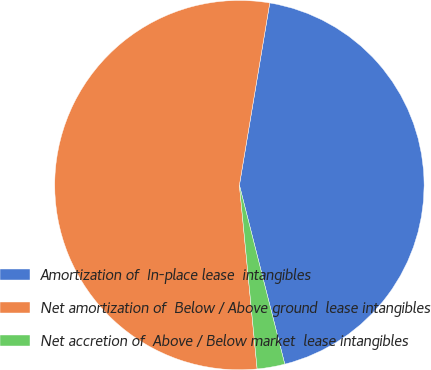<chart> <loc_0><loc_0><loc_500><loc_500><pie_chart><fcel>Amortization of  In-place lease  intangibles<fcel>Net amortization of  Below / Above ground  lease intangibles<fcel>Net accretion of  Above / Below market  lease intangibles<nl><fcel>43.42%<fcel>54.16%<fcel>2.42%<nl></chart> 